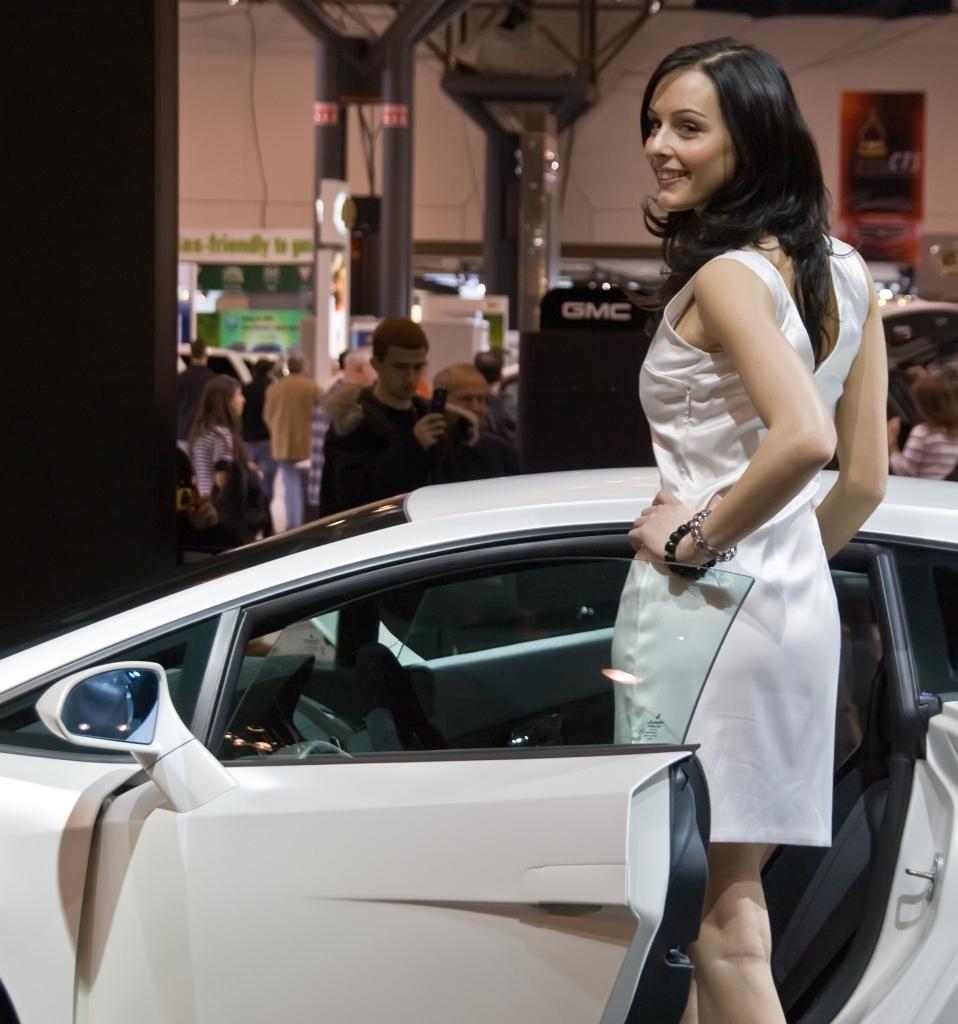Please provide a concise description of this image. In the center of the image we can see one woman is standing and she is in a white color costume and we can see she is smiling. Behind her, we can see a car, which is in a white color. In the background there is a wall, pole type structures, few people are standing, few people are holding some objects and a few other objects. 